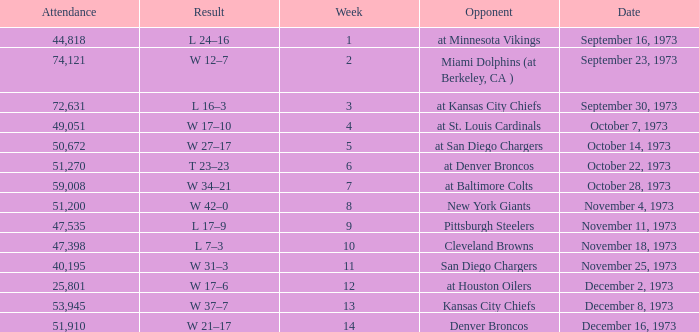What is the attendance for the game against the Kansas City Chiefs earlier than week 13? None. 